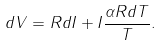Convert formula to latex. <formula><loc_0><loc_0><loc_500><loc_500>d V = R d I + I \frac { \alpha R d T } { T } .</formula> 